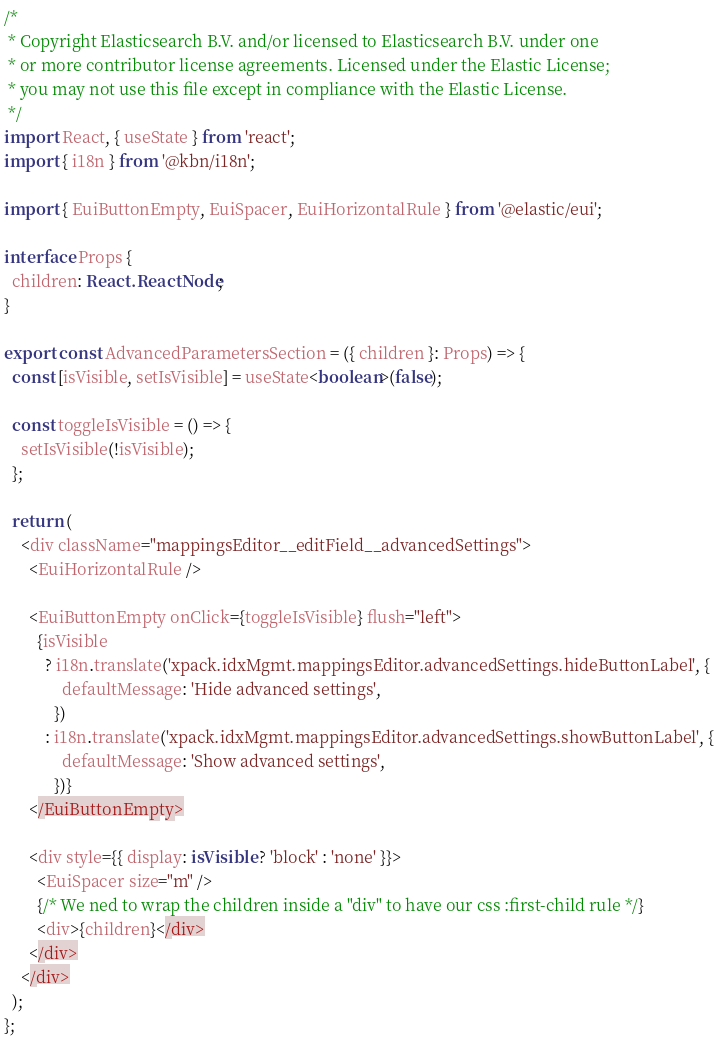Convert code to text. <code><loc_0><loc_0><loc_500><loc_500><_TypeScript_>/*
 * Copyright Elasticsearch B.V. and/or licensed to Elasticsearch B.V. under one
 * or more contributor license agreements. Licensed under the Elastic License;
 * you may not use this file except in compliance with the Elastic License.
 */
import React, { useState } from 'react';
import { i18n } from '@kbn/i18n';

import { EuiButtonEmpty, EuiSpacer, EuiHorizontalRule } from '@elastic/eui';

interface Props {
  children: React.ReactNode;
}

export const AdvancedParametersSection = ({ children }: Props) => {
  const [isVisible, setIsVisible] = useState<boolean>(false);

  const toggleIsVisible = () => {
    setIsVisible(!isVisible);
  };

  return (
    <div className="mappingsEditor__editField__advancedSettings">
      <EuiHorizontalRule />

      <EuiButtonEmpty onClick={toggleIsVisible} flush="left">
        {isVisible
          ? i18n.translate('xpack.idxMgmt.mappingsEditor.advancedSettings.hideButtonLabel', {
              defaultMessage: 'Hide advanced settings',
            })
          : i18n.translate('xpack.idxMgmt.mappingsEditor.advancedSettings.showButtonLabel', {
              defaultMessage: 'Show advanced settings',
            })}
      </EuiButtonEmpty>

      <div style={{ display: isVisible ? 'block' : 'none' }}>
        <EuiSpacer size="m" />
        {/* We ned to wrap the children inside a "div" to have our css :first-child rule */}
        <div>{children}</div>
      </div>
    </div>
  );
};
</code> 